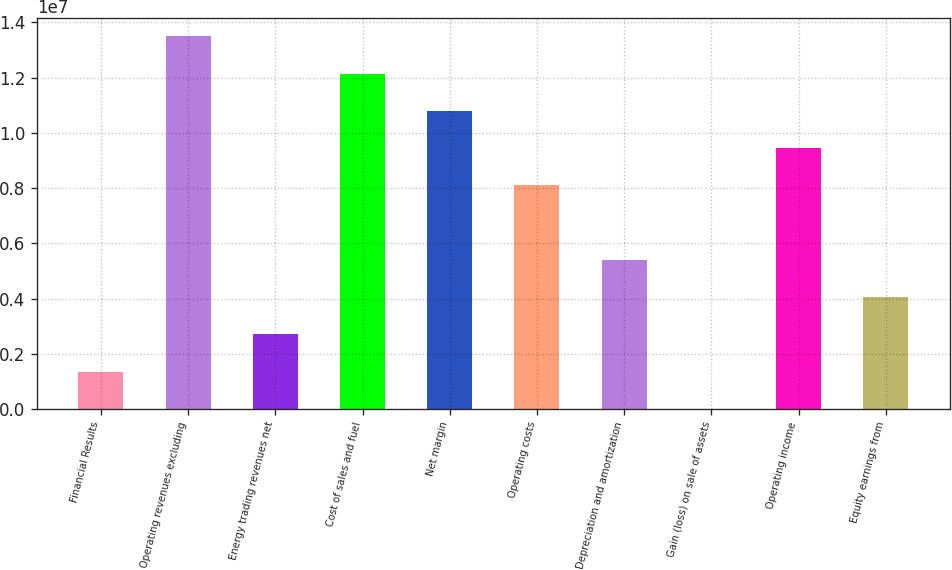Convert chart to OTSL. <chart><loc_0><loc_0><loc_500><loc_500><bar_chart><fcel>Financial Results<fcel>Operating revenues excluding<fcel>Energy trading revenues net<fcel>Cost of sales and fuel<fcel>Net margin<fcel>Operating costs<fcel>Depreciation and amortization<fcel>Gain (loss) on sale of assets<fcel>Operating income<fcel>Equity earnings from<nl><fcel>1.35052e+06<fcel>1.3488e+07<fcel>2.69913e+06<fcel>1.21394e+07<fcel>1.07908e+07<fcel>8.09358e+06<fcel>5.39636e+06<fcel>1909<fcel>9.44219e+06<fcel>4.04774e+06<nl></chart> 